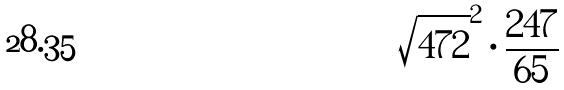<formula> <loc_0><loc_0><loc_500><loc_500>\sqrt { 4 7 2 } ^ { 2 } \cdot \frac { 2 4 7 } { 6 5 }</formula> 